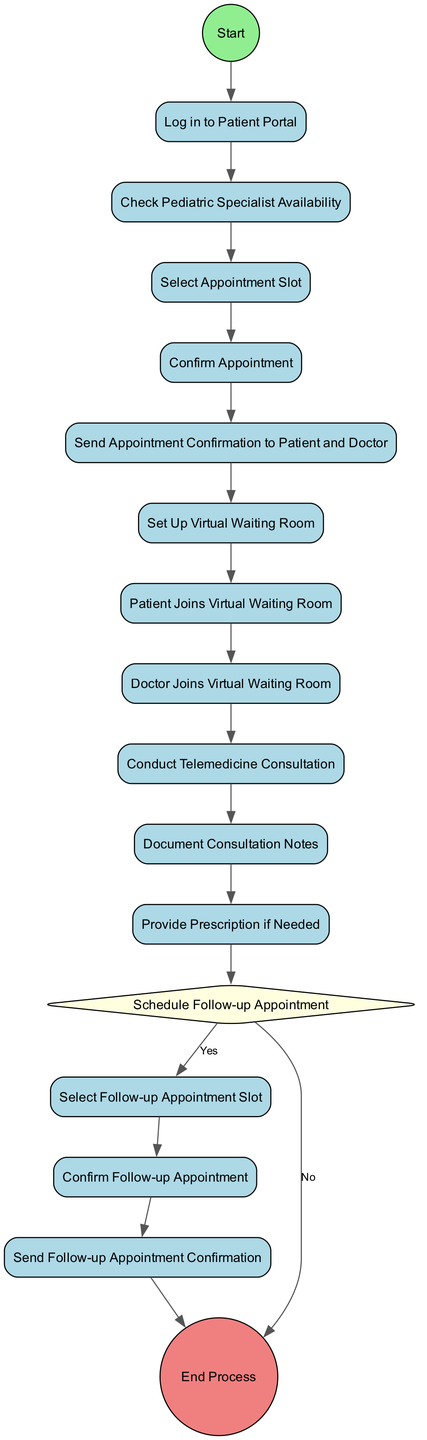What is the first action in the diagram? The diagram begins with the first action, which is identified as "Log in to Patient Portal." This is confirmed by examining the sequence of actions starting from the first node.
Answer: Log in to Patient Portal How many actions are there in total? Count the number of nodes categorized as actions. In the diagram, there are twelve actions listed, which can be confirmed by reviewing the activities section.
Answer: 12 What activity follows the "Confirm Appointment" action? The next activity in the flow following "Confirm Appointment" is "Send Appointment Confirmation to Patient and Doctor." This can be determined by looking at the directed transitions coming out of the "Confirm Appointment" node.
Answer: Send Appointment Confirmation to Patient and Doctor What is the decision point in the diagram? The decision point in the diagram is represented by "Schedule Follow-up Appointment," where it splits into two branches based on whether the answer is "Yes" or "No." This is clear from the structure of the diagram where it indicates a branching option.
Answer: Schedule Follow-up Appointment If the follow-up appointment is scheduled, which action occurs right before sending confirmation? If "Select Follow-up Appointment Slot" is executed after qualifying for a follow-up, the action just before sending the confirmation is "Confirm Follow-up Appointment." Analyzing the sequence reveals this connection.
Answer: Confirm Follow-up Appointment What is the final action in this process? The last action in the process, indicated by the end node, is "End Process." This terminates all activities after the necessary confirmations have been sent. The end node clearly marks the conclusion of the diagram flow.
Answer: End Process How many edges connect the nodes in the diagram? To find the total number of edges, count all transitions connecting the activity nodes. There are sixteen edges as detailed in the transitions section of the diagram.
Answer: 16 What happens after "Conduct Telemedicine Consultation"? Following "Conduct Telemedicine Consultation," the next action is "Document Consultation Notes." This establishes a direct link showing the sequence in which the actions need to be performed.
Answer: Document Consultation Notes What is the condition for transitioning to "Select Follow-up Appointment Slot"? The only condition that leads to "Select Follow-up Appointment Slot" is a positive response to the question posed at "Schedule Follow-up Appointment," specifically if the answer is "Yes." This establishes a conditional path in the workflow.
Answer: Yes 